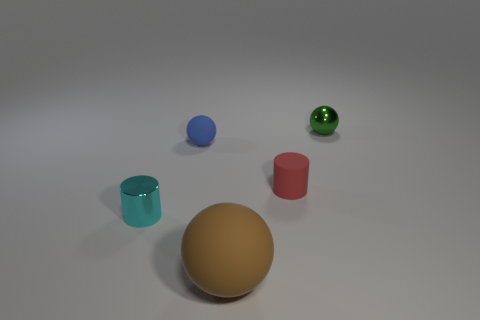How big is the cylinder that is right of the metallic object that is in front of the ball that is behind the blue rubber ball?
Offer a terse response. Small. Does the small metallic cylinder have the same color as the rubber cylinder?
Give a very brief answer. No. Is there any other thing that has the same size as the brown matte object?
Your answer should be compact. No. There is a small blue matte thing; how many red cylinders are behind it?
Your answer should be very brief. 0. Are there the same number of tiny green metal things that are in front of the small blue rubber object and tiny shiny cylinders?
Provide a short and direct response. No. What number of things are either small red blocks or big spheres?
Your answer should be compact. 1. Is there any other thing that has the same shape as the red object?
Make the answer very short. Yes. There is a small green thing behind the thing in front of the tiny cyan cylinder; what is its shape?
Give a very brief answer. Sphere. There is a tiny red thing that is made of the same material as the big sphere; what is its shape?
Give a very brief answer. Cylinder. There is a rubber sphere that is behind the metal thing that is on the left side of the brown thing; what size is it?
Give a very brief answer. Small. 